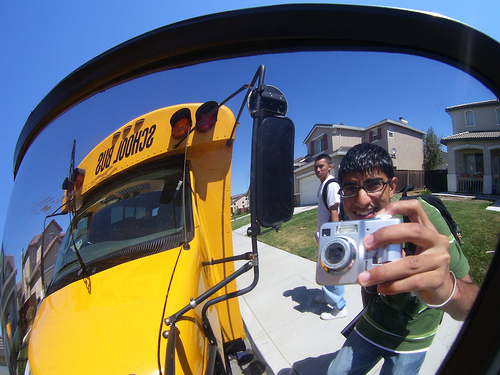Please provide the bounding box coordinate of the region this sentence describes: boy standing on sidewalk. The bounding box for the region described by 'boy standing on sidewalk' is [0.46, 0.57, 0.94, 0.87]. 